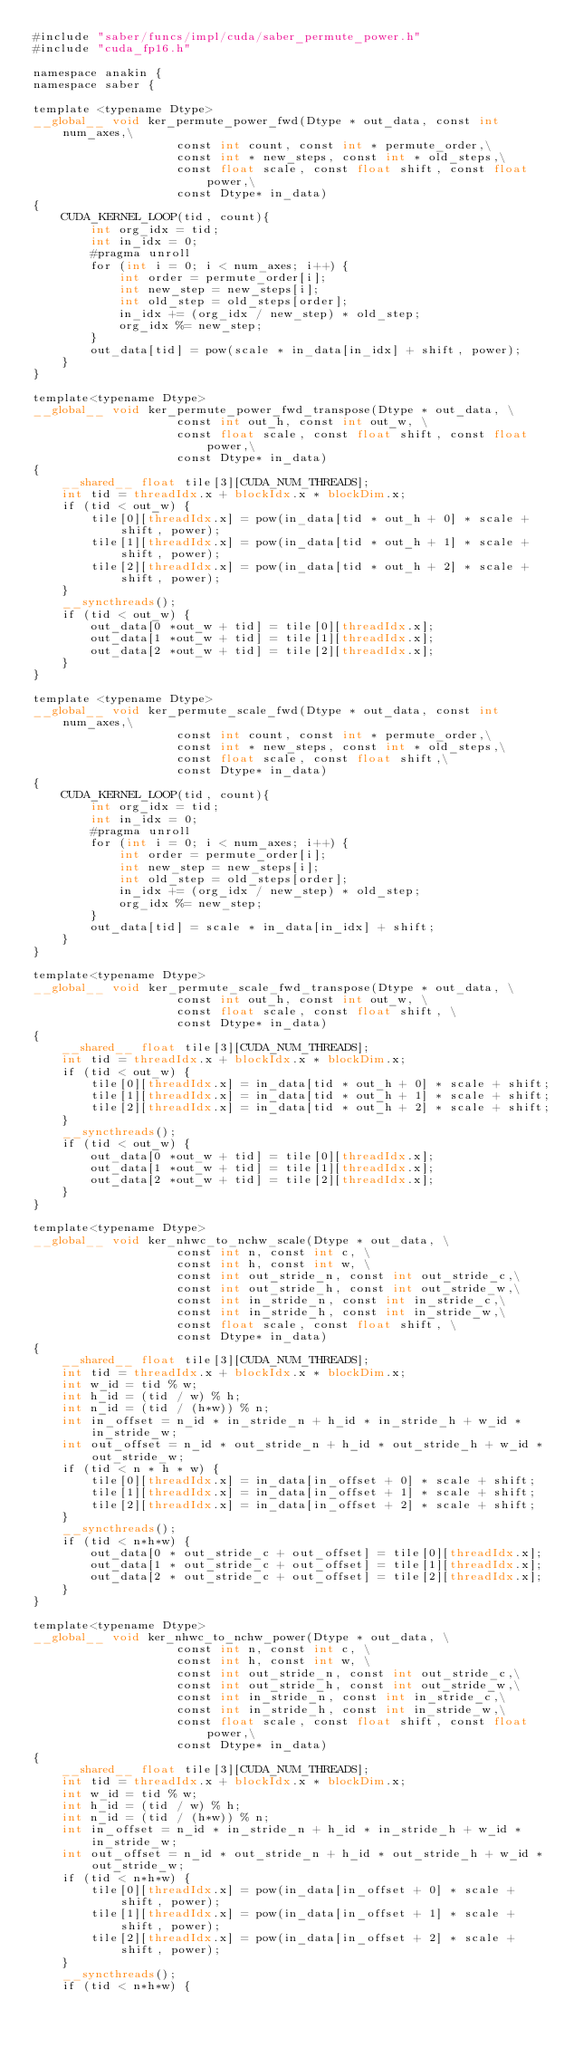<code> <loc_0><loc_0><loc_500><loc_500><_Cuda_>#include "saber/funcs/impl/cuda/saber_permute_power.h"
#include "cuda_fp16.h"

namespace anakin {
namespace saber {

template <typename Dtype>
__global__ void ker_permute_power_fwd(Dtype * out_data, const int num_axes,\
                    const int count, const int * permute_order,\
                    const int * new_steps, const int * old_steps,\
                    const float scale, const float shift, const float power,\
                    const Dtype* in_data)
{
    CUDA_KERNEL_LOOP(tid, count){
        int org_idx = tid;
        int in_idx = 0;
        #pragma unroll
        for (int i = 0; i < num_axes; i++) {
            int order = permute_order[i];
            int new_step = new_steps[i];
            int old_step = old_steps[order];
            in_idx += (org_idx / new_step) * old_step;
            org_idx %= new_step;
        }
        out_data[tid] = pow(scale * in_data[in_idx] + shift, power);
    }
}

template<typename Dtype>
__global__ void ker_permute_power_fwd_transpose(Dtype * out_data, \
                    const int out_h, const int out_w, \
                    const float scale, const float shift, const float power,\
                    const Dtype* in_data)
{
    __shared__ float tile[3][CUDA_NUM_THREADS];
    int tid = threadIdx.x + blockIdx.x * blockDim.x;
    if (tid < out_w) {
        tile[0][threadIdx.x] = pow(in_data[tid * out_h + 0] * scale + shift, power);
        tile[1][threadIdx.x] = pow(in_data[tid * out_h + 1] * scale + shift, power);
        tile[2][threadIdx.x] = pow(in_data[tid * out_h + 2] * scale + shift, power);
    }
    __syncthreads();
    if (tid < out_w) {
        out_data[0 *out_w + tid] = tile[0][threadIdx.x];
        out_data[1 *out_w + tid] = tile[1][threadIdx.x];
        out_data[2 *out_w + tid] = tile[2][threadIdx.x];
    }
}

template <typename Dtype>
__global__ void ker_permute_scale_fwd(Dtype * out_data, const int num_axes,\
                    const int count, const int * permute_order,\
                    const int * new_steps, const int * old_steps,\
                    const float scale, const float shift,\
                    const Dtype* in_data)
{
    CUDA_KERNEL_LOOP(tid, count){
        int org_idx = tid;
        int in_idx = 0;
        #pragma unroll
        for (int i = 0; i < num_axes; i++) {
            int order = permute_order[i];
            int new_step = new_steps[i];
            int old_step = old_steps[order];
            in_idx += (org_idx / new_step) * old_step;
            org_idx %= new_step;
        }
        out_data[tid] = scale * in_data[in_idx] + shift;
    }
}

template<typename Dtype>
__global__ void ker_permute_scale_fwd_transpose(Dtype * out_data, \
                    const int out_h, const int out_w, \
                    const float scale, const float shift, \
                    const Dtype* in_data)
{
    __shared__ float tile[3][CUDA_NUM_THREADS];
    int tid = threadIdx.x + blockIdx.x * blockDim.x;
    if (tid < out_w) {
        tile[0][threadIdx.x] = in_data[tid * out_h + 0] * scale + shift;
        tile[1][threadIdx.x] = in_data[tid * out_h + 1] * scale + shift;
        tile[2][threadIdx.x] = in_data[tid * out_h + 2] * scale + shift;
    }
    __syncthreads();
    if (tid < out_w) {
        out_data[0 *out_w + tid] = tile[0][threadIdx.x];
        out_data[1 *out_w + tid] = tile[1][threadIdx.x];
        out_data[2 *out_w + tid] = tile[2][threadIdx.x];
    }
}

template<typename Dtype>
__global__ void ker_nhwc_to_nchw_scale(Dtype * out_data, \
                    const int n, const int c, \
                    const int h, const int w, \
                    const int out_stride_n, const int out_stride_c,\
                    const int out_stride_h, const int out_stride_w,\
                    const int in_stride_n, const int in_stride_c,\
                    const int in_stride_h, const int in_stride_w,\
                    const float scale, const float shift, \
                    const Dtype* in_data)
{
    __shared__ float tile[3][CUDA_NUM_THREADS];
    int tid = threadIdx.x + blockIdx.x * blockDim.x;
    int w_id = tid % w;
    int h_id = (tid / w) % h;
    int n_id = (tid / (h*w)) % n;
    int in_offset = n_id * in_stride_n + h_id * in_stride_h + w_id * in_stride_w;
    int out_offset = n_id * out_stride_n + h_id * out_stride_h + w_id * out_stride_w;
    if (tid < n * h * w) {
        tile[0][threadIdx.x] = in_data[in_offset + 0] * scale + shift;
        tile[1][threadIdx.x] = in_data[in_offset + 1] * scale + shift;
        tile[2][threadIdx.x] = in_data[in_offset + 2] * scale + shift;
    }
    __syncthreads();
    if (tid < n*h*w) {
        out_data[0 * out_stride_c + out_offset] = tile[0][threadIdx.x];
        out_data[1 * out_stride_c + out_offset] = tile[1][threadIdx.x];
        out_data[2 * out_stride_c + out_offset] = tile[2][threadIdx.x];
    }
}

template<typename Dtype>
__global__ void ker_nhwc_to_nchw_power(Dtype * out_data, \
                    const int n, const int c, \
                    const int h, const int w, \
                    const int out_stride_n, const int out_stride_c,\
                    const int out_stride_h, const int out_stride_w,\
                    const int in_stride_n, const int in_stride_c,\
                    const int in_stride_h, const int in_stride_w,\
                    const float scale, const float shift, const float power,\
                    const Dtype* in_data)
{
    __shared__ float tile[3][CUDA_NUM_THREADS];
    int tid = threadIdx.x + blockIdx.x * blockDim.x;
    int w_id = tid % w;
    int h_id = (tid / w) % h;
    int n_id = (tid / (h*w)) % n;
    int in_offset = n_id * in_stride_n + h_id * in_stride_h + w_id * in_stride_w;
    int out_offset = n_id * out_stride_n + h_id * out_stride_h + w_id * out_stride_w;
    if (tid < n*h*w) {
        tile[0][threadIdx.x] = pow(in_data[in_offset + 0] * scale + shift, power);
        tile[1][threadIdx.x] = pow(in_data[in_offset + 1] * scale + shift, power);
        tile[2][threadIdx.x] = pow(in_data[in_offset + 2] * scale + shift, power);
    }
    __syncthreads();
    if (tid < n*h*w) {</code> 